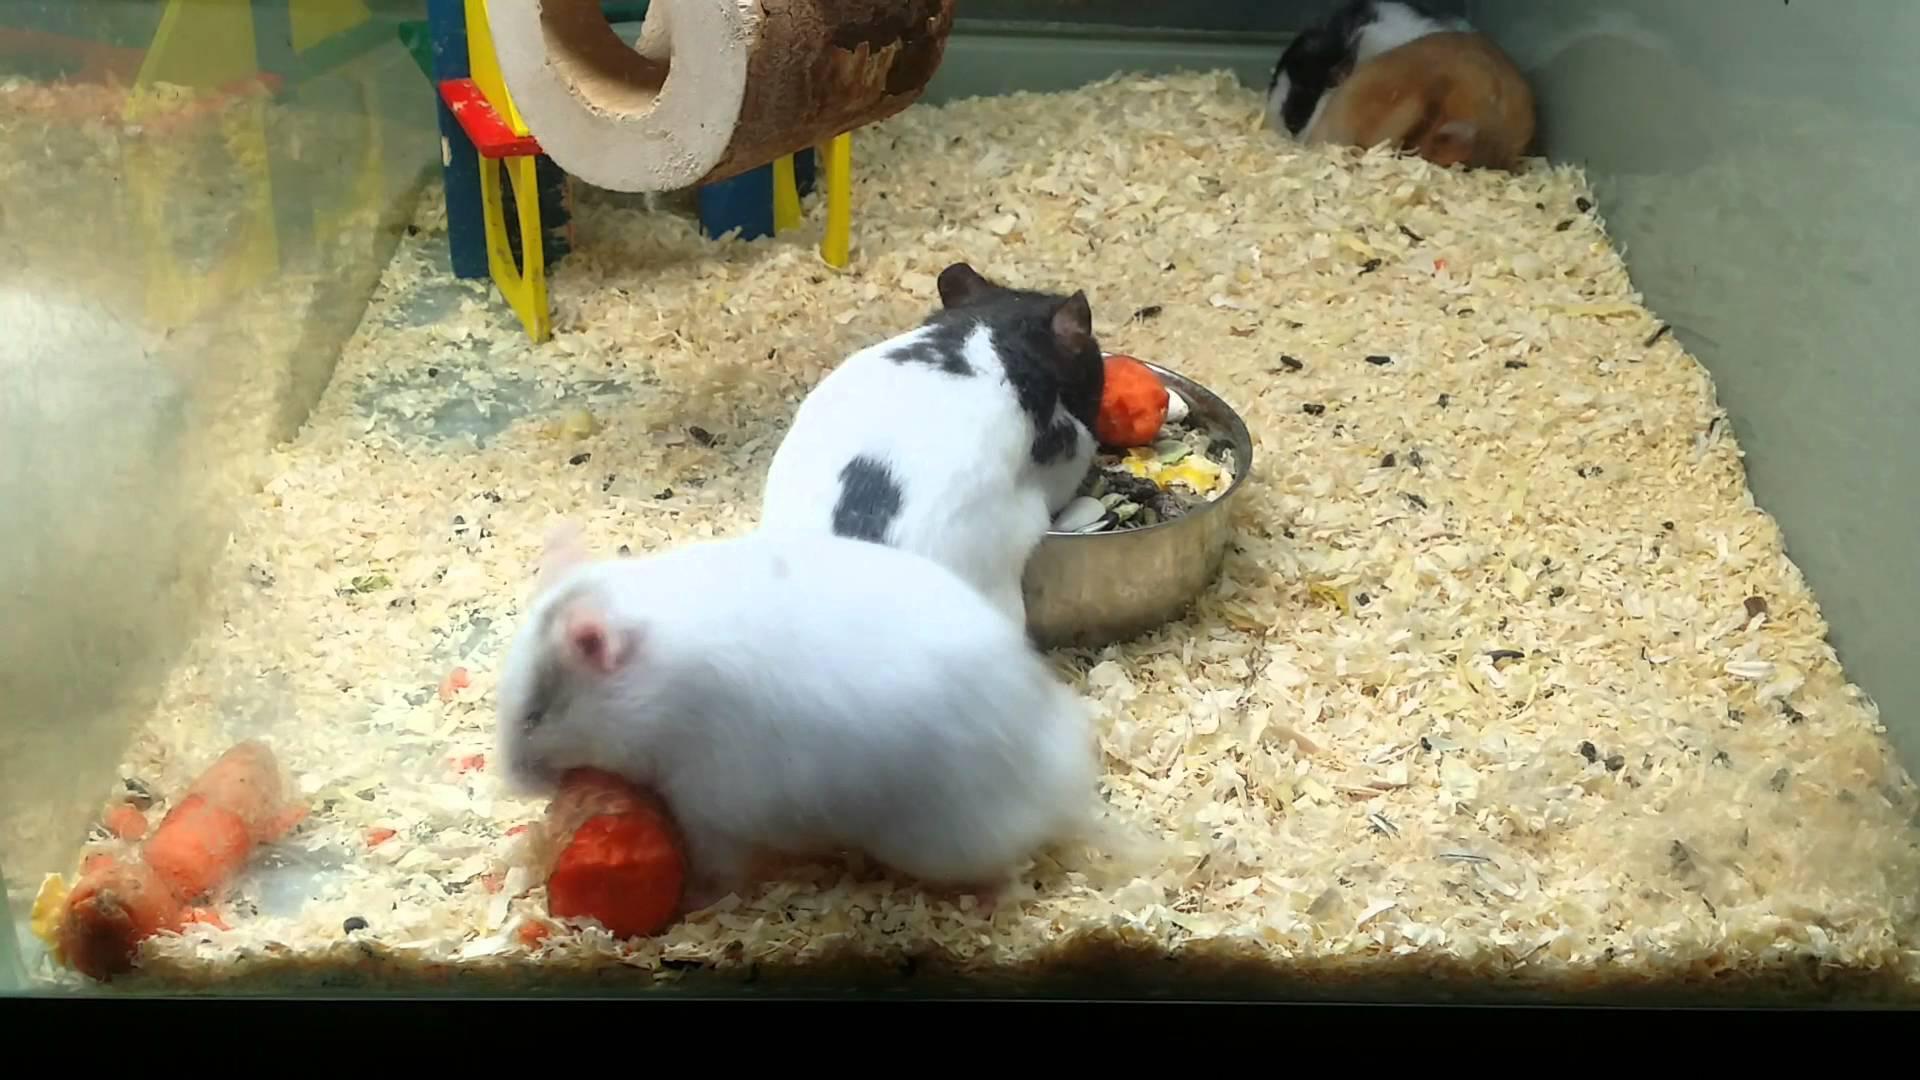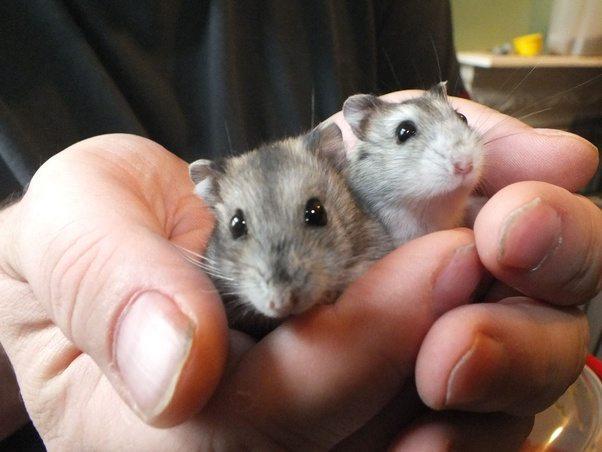The first image is the image on the left, the second image is the image on the right. Given the left and right images, does the statement "A hamster is standing on its hind legs with its front legs up and not touching the ground." hold true? Answer yes or no. No. The first image is the image on the left, the second image is the image on the right. For the images displayed, is the sentence "An image contains two hamsters and some part of a human." factually correct? Answer yes or no. Yes. 